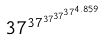<formula> <loc_0><loc_0><loc_500><loc_500>3 7 ^ { 3 7 ^ { 3 7 ^ { 3 7 ^ { 3 7 ^ { 4 . 8 5 9 } } } } }</formula> 